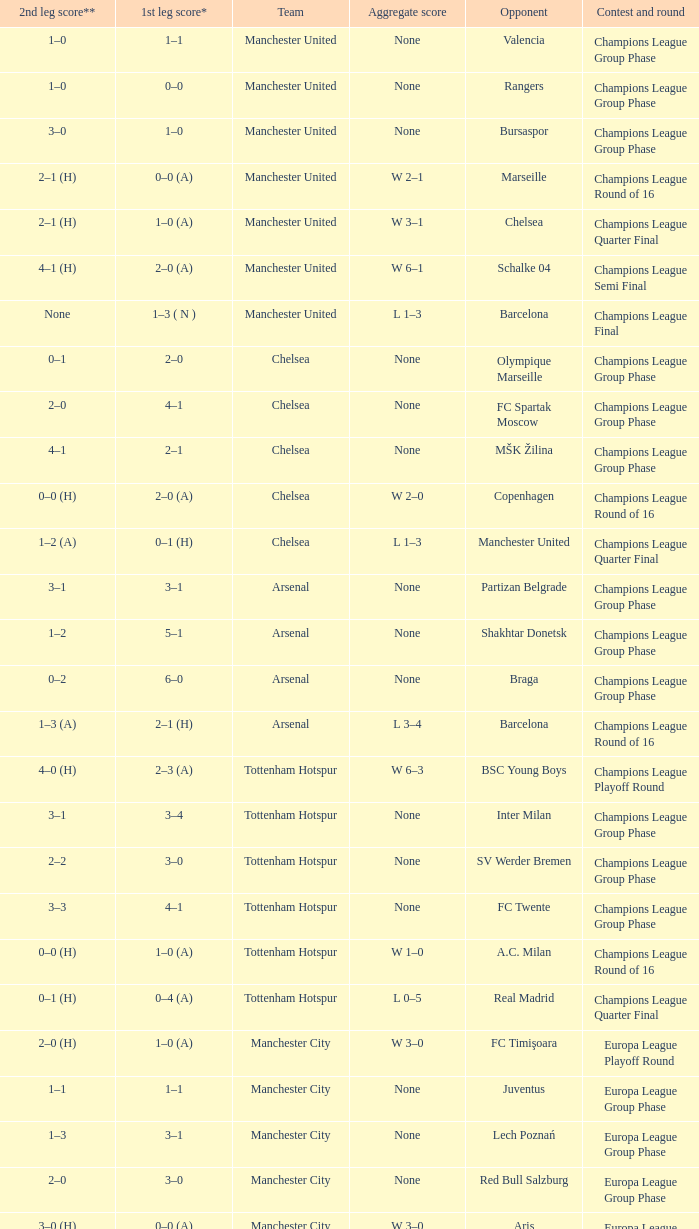During the initial leg of the liverpool versus steaua bucureşti match, how many goals were scored by each side? 4–1. 